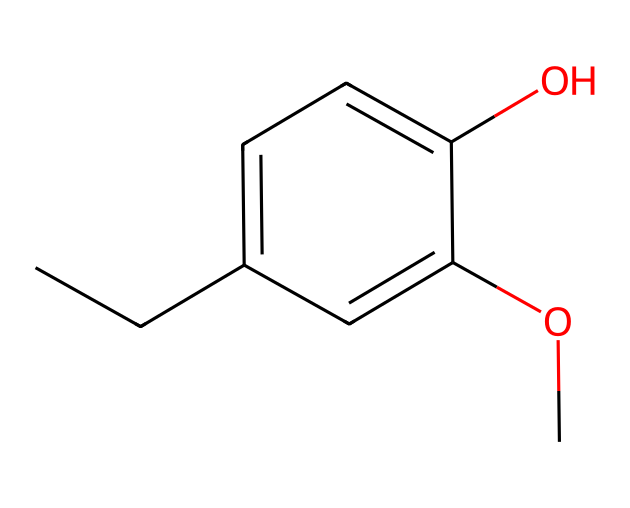What is the primary functional group present in this chemical? The chemical structure contains a hydroxyl group (-OH) directly attached to one of the carbon atoms in the aromatic ring, which is characteristic of phenols.
Answer: hydroxyl group How many carbon atoms are in this chemical? By analyzing the SMILES notation, there are 10 carbon atoms present in total, including those in the aromatic ring and the aliphatic chain.
Answer: ten What type of isomerism can this chemical exhibit? This phenolic compound can exhibit positional isomerism due to the presence of substituents on the benzene ring that can vary in position, such as methoxy and hydroxyl groups.
Answer: positional isomerism Why might this compound be used in air fresheners? Eugenol, the compound represented, contains aromatic and aromatic ether components which can provide a pleasant scent and are effective in masking odors; these properties are desirable in air fresheners.
Answer: pleasant scent What is the total number of oxygen atoms in this chemical? From the structure, there are two distinct oxygen atoms: one in the hydroxyl (-OH) group and the other in the methoxy (-OCH3) group.
Answer: two What characteristic of phenols contributes to their antiseptic properties? The presence of the hydroxyl group enhances the chemical's ability to disrupt cell membranes of bacteria, thus providing antiseptic properties common to phenolic compounds.
Answer: hydroxyl group 